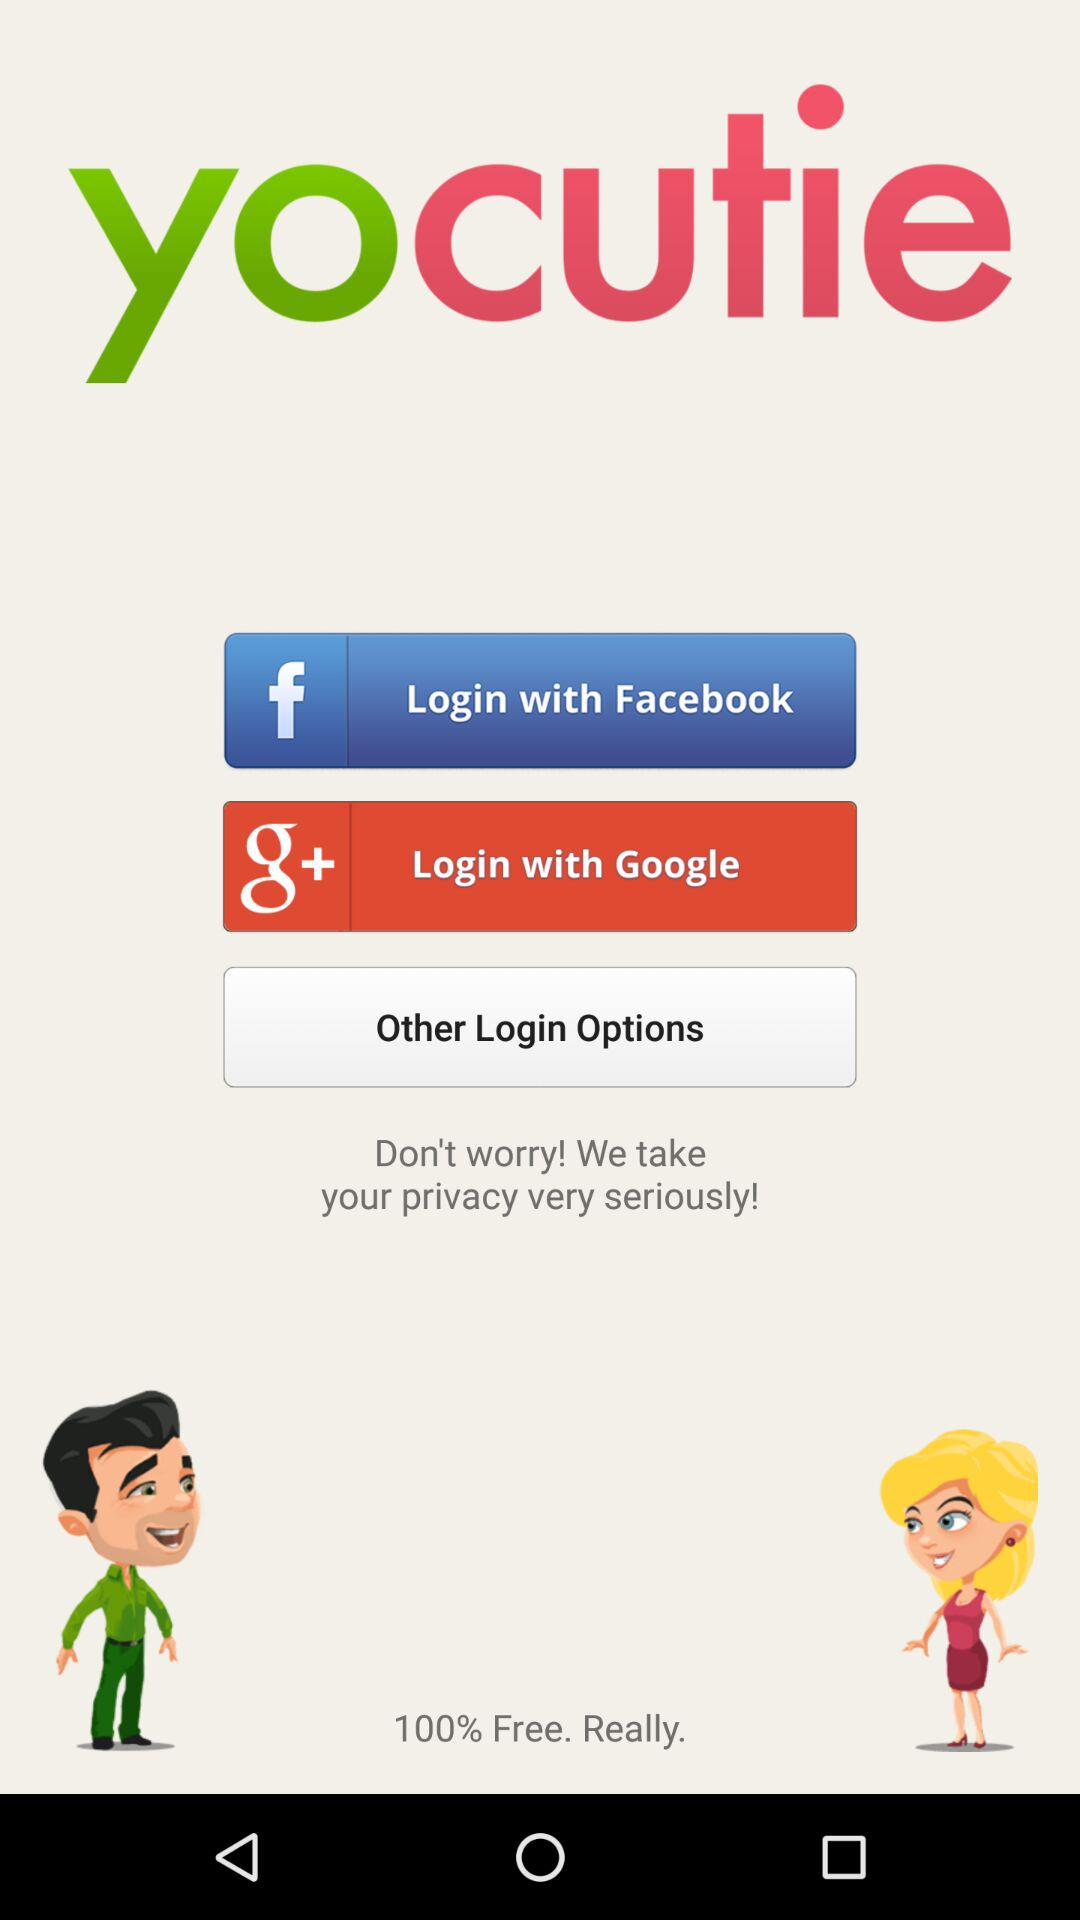Which are the login options? The login options are "Facebook" and "Google". 